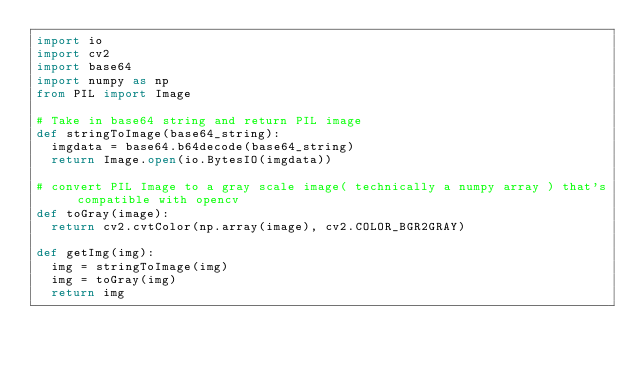<code> <loc_0><loc_0><loc_500><loc_500><_Python_>import io
import cv2
import base64 
import numpy as np
from PIL import Image

# Take in base64 string and return PIL image
def stringToImage(base64_string):
  imgdata = base64.b64decode(base64_string)
  return Image.open(io.BytesIO(imgdata))

# convert PIL Image to a gray scale image( technically a numpy array ) that's compatible with opencv
def toGray(image):
  return cv2.cvtColor(np.array(image), cv2.COLOR_BGR2GRAY)

def getImg(img):
  img = stringToImage(img)
  img = toGray(img)
  return img</code> 